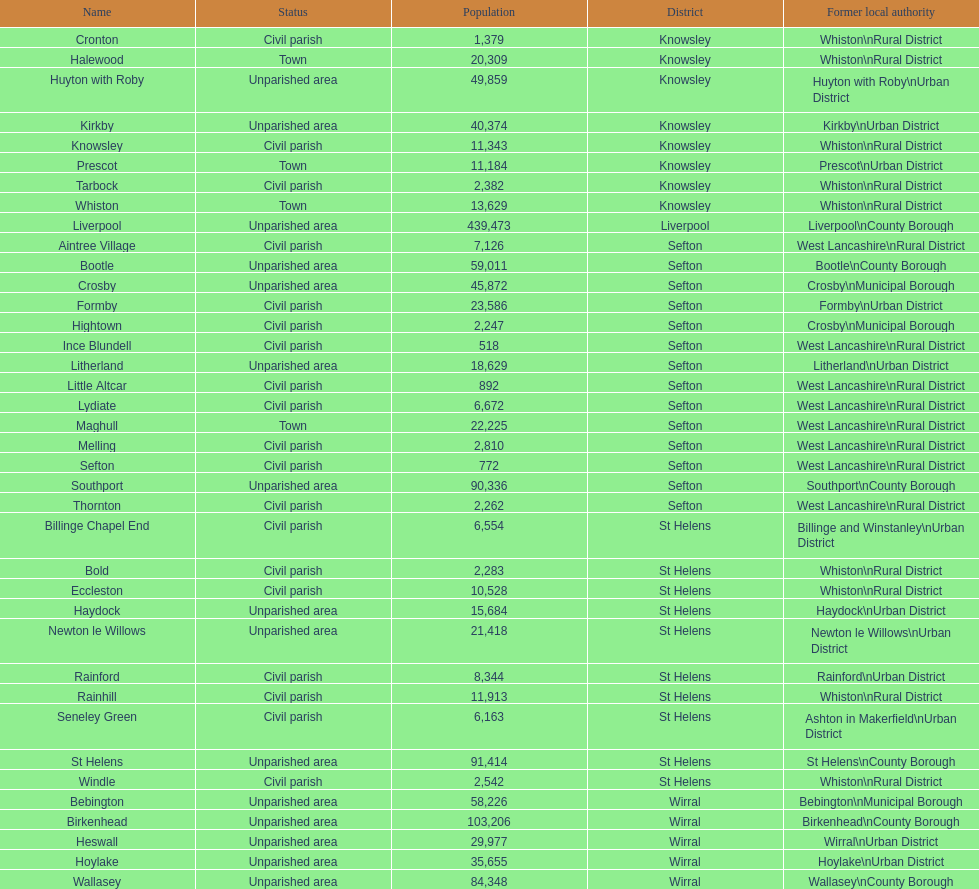How many areas are unparished areas? 15. 